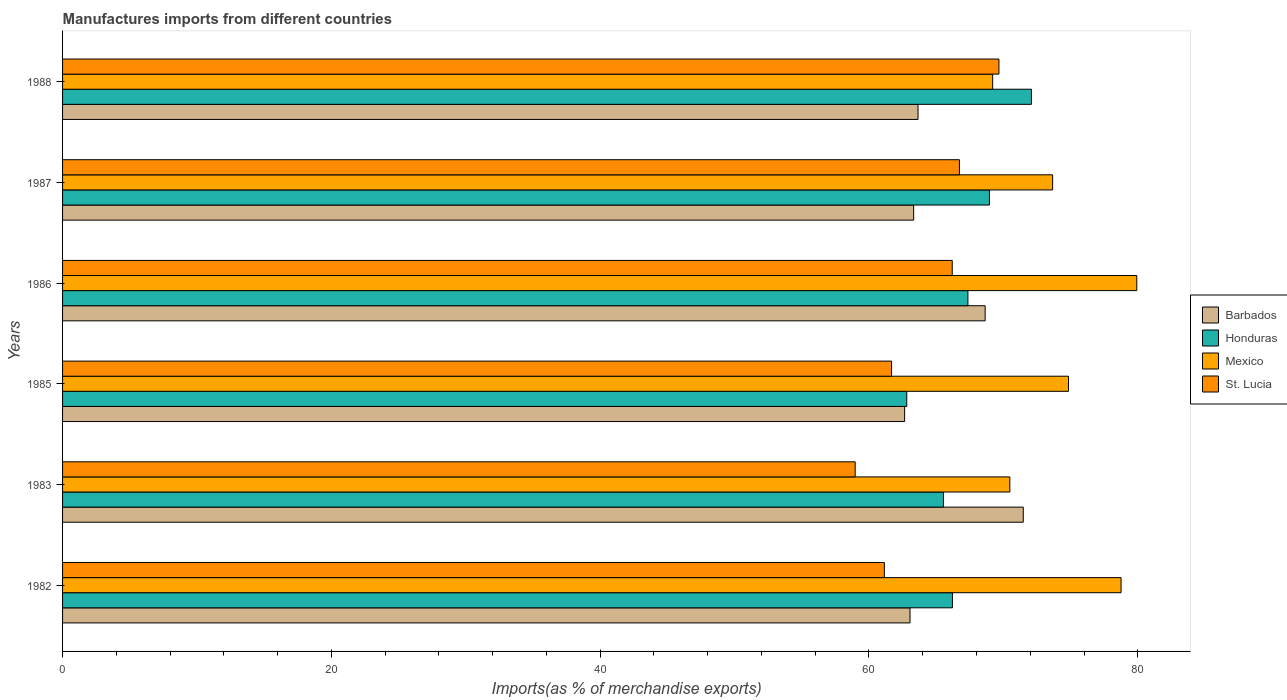How many different coloured bars are there?
Make the answer very short. 4. In how many cases, is the number of bars for a given year not equal to the number of legend labels?
Offer a terse response. 0. What is the percentage of imports to different countries in Mexico in 1985?
Keep it short and to the point. 74.84. Across all years, what is the maximum percentage of imports to different countries in Barbados?
Your answer should be very brief. 71.48. Across all years, what is the minimum percentage of imports to different countries in Honduras?
Your answer should be compact. 62.81. In which year was the percentage of imports to different countries in Mexico maximum?
Provide a succinct answer. 1986. What is the total percentage of imports to different countries in Honduras in the graph?
Offer a terse response. 402.97. What is the difference between the percentage of imports to different countries in Honduras in 1986 and that in 1988?
Offer a very short reply. -4.73. What is the difference between the percentage of imports to different countries in Mexico in 1987 and the percentage of imports to different countries in Barbados in 1983?
Ensure brevity in your answer.  2.19. What is the average percentage of imports to different countries in Honduras per year?
Your answer should be compact. 67.16. In the year 1985, what is the difference between the percentage of imports to different countries in St. Lucia and percentage of imports to different countries in Barbados?
Provide a succinct answer. -0.97. In how many years, is the percentage of imports to different countries in Mexico greater than 76 %?
Ensure brevity in your answer.  2. What is the ratio of the percentage of imports to different countries in St. Lucia in 1985 to that in 1986?
Provide a short and direct response. 0.93. Is the percentage of imports to different countries in St. Lucia in 1985 less than that in 1988?
Provide a succinct answer. Yes. What is the difference between the highest and the second highest percentage of imports to different countries in Honduras?
Make the answer very short. 3.12. What is the difference between the highest and the lowest percentage of imports to different countries in Barbados?
Give a very brief answer. 8.83. Is the sum of the percentage of imports to different countries in St. Lucia in 1982 and 1986 greater than the maximum percentage of imports to different countries in Barbados across all years?
Provide a succinct answer. Yes. What does the 2nd bar from the top in 1987 represents?
Provide a short and direct response. Mexico. What does the 3rd bar from the bottom in 1983 represents?
Your answer should be compact. Mexico. Is it the case that in every year, the sum of the percentage of imports to different countries in Barbados and percentage of imports to different countries in St. Lucia is greater than the percentage of imports to different countries in Honduras?
Ensure brevity in your answer.  Yes. Are all the bars in the graph horizontal?
Offer a very short reply. Yes. Are the values on the major ticks of X-axis written in scientific E-notation?
Keep it short and to the point. No. Does the graph contain grids?
Provide a succinct answer. No. How many legend labels are there?
Provide a succinct answer. 4. How are the legend labels stacked?
Keep it short and to the point. Vertical. What is the title of the graph?
Make the answer very short. Manufactures imports from different countries. Does "Netherlands" appear as one of the legend labels in the graph?
Ensure brevity in your answer.  No. What is the label or title of the X-axis?
Keep it short and to the point. Imports(as % of merchandise exports). What is the label or title of the Y-axis?
Offer a terse response. Years. What is the Imports(as % of merchandise exports) in Barbados in 1982?
Keep it short and to the point. 63.05. What is the Imports(as % of merchandise exports) in Honduras in 1982?
Make the answer very short. 66.21. What is the Imports(as % of merchandise exports) in Mexico in 1982?
Offer a very short reply. 78.76. What is the Imports(as % of merchandise exports) of St. Lucia in 1982?
Ensure brevity in your answer.  61.14. What is the Imports(as % of merchandise exports) in Barbados in 1983?
Offer a terse response. 71.48. What is the Imports(as % of merchandise exports) of Honduras in 1983?
Provide a short and direct response. 65.54. What is the Imports(as % of merchandise exports) of Mexico in 1983?
Ensure brevity in your answer.  70.48. What is the Imports(as % of merchandise exports) of St. Lucia in 1983?
Provide a short and direct response. 58.97. What is the Imports(as % of merchandise exports) in Barbados in 1985?
Provide a succinct answer. 62.65. What is the Imports(as % of merchandise exports) in Honduras in 1985?
Your answer should be compact. 62.81. What is the Imports(as % of merchandise exports) of Mexico in 1985?
Offer a very short reply. 74.84. What is the Imports(as % of merchandise exports) in St. Lucia in 1985?
Provide a succinct answer. 61.68. What is the Imports(as % of merchandise exports) of Barbados in 1986?
Make the answer very short. 68.64. What is the Imports(as % of merchandise exports) of Honduras in 1986?
Make the answer very short. 67.36. What is the Imports(as % of merchandise exports) in Mexico in 1986?
Keep it short and to the point. 79.93. What is the Imports(as % of merchandise exports) of St. Lucia in 1986?
Your answer should be compact. 66.19. What is the Imports(as % of merchandise exports) of Barbados in 1987?
Provide a succinct answer. 63.32. What is the Imports(as % of merchandise exports) of Honduras in 1987?
Provide a short and direct response. 68.96. What is the Imports(as % of merchandise exports) in Mexico in 1987?
Offer a terse response. 73.66. What is the Imports(as % of merchandise exports) of St. Lucia in 1987?
Your answer should be very brief. 66.73. What is the Imports(as % of merchandise exports) in Barbados in 1988?
Provide a short and direct response. 63.65. What is the Imports(as % of merchandise exports) of Honduras in 1988?
Your answer should be very brief. 72.09. What is the Imports(as % of merchandise exports) in Mexico in 1988?
Your response must be concise. 69.2. What is the Imports(as % of merchandise exports) in St. Lucia in 1988?
Make the answer very short. 69.67. Across all years, what is the maximum Imports(as % of merchandise exports) of Barbados?
Make the answer very short. 71.48. Across all years, what is the maximum Imports(as % of merchandise exports) of Honduras?
Give a very brief answer. 72.09. Across all years, what is the maximum Imports(as % of merchandise exports) of Mexico?
Your answer should be very brief. 79.93. Across all years, what is the maximum Imports(as % of merchandise exports) in St. Lucia?
Make the answer very short. 69.67. Across all years, what is the minimum Imports(as % of merchandise exports) in Barbados?
Give a very brief answer. 62.65. Across all years, what is the minimum Imports(as % of merchandise exports) in Honduras?
Your answer should be compact. 62.81. Across all years, what is the minimum Imports(as % of merchandise exports) in Mexico?
Keep it short and to the point. 69.2. Across all years, what is the minimum Imports(as % of merchandise exports) of St. Lucia?
Your response must be concise. 58.97. What is the total Imports(as % of merchandise exports) in Barbados in the graph?
Your response must be concise. 392.8. What is the total Imports(as % of merchandise exports) in Honduras in the graph?
Your answer should be compact. 402.97. What is the total Imports(as % of merchandise exports) in Mexico in the graph?
Provide a succinct answer. 446.87. What is the total Imports(as % of merchandise exports) of St. Lucia in the graph?
Your answer should be compact. 384.39. What is the difference between the Imports(as % of merchandise exports) of Barbados in 1982 and that in 1983?
Provide a short and direct response. -8.43. What is the difference between the Imports(as % of merchandise exports) of Honduras in 1982 and that in 1983?
Keep it short and to the point. 0.67. What is the difference between the Imports(as % of merchandise exports) in Mexico in 1982 and that in 1983?
Offer a very short reply. 8.27. What is the difference between the Imports(as % of merchandise exports) of St. Lucia in 1982 and that in 1983?
Your answer should be very brief. 2.17. What is the difference between the Imports(as % of merchandise exports) in Barbados in 1982 and that in 1985?
Provide a succinct answer. 0.4. What is the difference between the Imports(as % of merchandise exports) in Honduras in 1982 and that in 1985?
Ensure brevity in your answer.  3.4. What is the difference between the Imports(as % of merchandise exports) of Mexico in 1982 and that in 1985?
Offer a terse response. 3.91. What is the difference between the Imports(as % of merchandise exports) in St. Lucia in 1982 and that in 1985?
Keep it short and to the point. -0.54. What is the difference between the Imports(as % of merchandise exports) of Barbados in 1982 and that in 1986?
Your response must be concise. -5.59. What is the difference between the Imports(as % of merchandise exports) in Honduras in 1982 and that in 1986?
Provide a succinct answer. -1.15. What is the difference between the Imports(as % of merchandise exports) of Mexico in 1982 and that in 1986?
Ensure brevity in your answer.  -1.17. What is the difference between the Imports(as % of merchandise exports) of St. Lucia in 1982 and that in 1986?
Offer a terse response. -5.05. What is the difference between the Imports(as % of merchandise exports) of Barbados in 1982 and that in 1987?
Your answer should be compact. -0.27. What is the difference between the Imports(as % of merchandise exports) of Honduras in 1982 and that in 1987?
Your response must be concise. -2.75. What is the difference between the Imports(as % of merchandise exports) in Mexico in 1982 and that in 1987?
Ensure brevity in your answer.  5.09. What is the difference between the Imports(as % of merchandise exports) in St. Lucia in 1982 and that in 1987?
Your response must be concise. -5.58. What is the difference between the Imports(as % of merchandise exports) of Barbados in 1982 and that in 1988?
Give a very brief answer. -0.6. What is the difference between the Imports(as % of merchandise exports) in Honduras in 1982 and that in 1988?
Offer a very short reply. -5.88. What is the difference between the Imports(as % of merchandise exports) in Mexico in 1982 and that in 1988?
Offer a terse response. 9.55. What is the difference between the Imports(as % of merchandise exports) in St. Lucia in 1982 and that in 1988?
Your answer should be very brief. -8.52. What is the difference between the Imports(as % of merchandise exports) in Barbados in 1983 and that in 1985?
Offer a terse response. 8.83. What is the difference between the Imports(as % of merchandise exports) in Honduras in 1983 and that in 1985?
Make the answer very short. 2.73. What is the difference between the Imports(as % of merchandise exports) in Mexico in 1983 and that in 1985?
Make the answer very short. -4.36. What is the difference between the Imports(as % of merchandise exports) of St. Lucia in 1983 and that in 1985?
Offer a terse response. -2.71. What is the difference between the Imports(as % of merchandise exports) of Barbados in 1983 and that in 1986?
Ensure brevity in your answer.  2.84. What is the difference between the Imports(as % of merchandise exports) of Honduras in 1983 and that in 1986?
Give a very brief answer. -1.82. What is the difference between the Imports(as % of merchandise exports) of Mexico in 1983 and that in 1986?
Offer a terse response. -9.44. What is the difference between the Imports(as % of merchandise exports) of St. Lucia in 1983 and that in 1986?
Make the answer very short. -7.22. What is the difference between the Imports(as % of merchandise exports) of Barbados in 1983 and that in 1987?
Offer a terse response. 8.16. What is the difference between the Imports(as % of merchandise exports) in Honduras in 1983 and that in 1987?
Your response must be concise. -3.42. What is the difference between the Imports(as % of merchandise exports) in Mexico in 1983 and that in 1987?
Your answer should be compact. -3.18. What is the difference between the Imports(as % of merchandise exports) in St. Lucia in 1983 and that in 1987?
Your answer should be very brief. -7.76. What is the difference between the Imports(as % of merchandise exports) of Barbados in 1983 and that in 1988?
Provide a short and direct response. 7.83. What is the difference between the Imports(as % of merchandise exports) of Honduras in 1983 and that in 1988?
Your response must be concise. -6.55. What is the difference between the Imports(as % of merchandise exports) of Mexico in 1983 and that in 1988?
Ensure brevity in your answer.  1.28. What is the difference between the Imports(as % of merchandise exports) of St. Lucia in 1983 and that in 1988?
Keep it short and to the point. -10.7. What is the difference between the Imports(as % of merchandise exports) of Barbados in 1985 and that in 1986?
Your response must be concise. -5.99. What is the difference between the Imports(as % of merchandise exports) of Honduras in 1985 and that in 1986?
Provide a succinct answer. -4.55. What is the difference between the Imports(as % of merchandise exports) of Mexico in 1985 and that in 1986?
Provide a short and direct response. -5.08. What is the difference between the Imports(as % of merchandise exports) of St. Lucia in 1985 and that in 1986?
Your answer should be very brief. -4.51. What is the difference between the Imports(as % of merchandise exports) of Barbados in 1985 and that in 1987?
Keep it short and to the point. -0.67. What is the difference between the Imports(as % of merchandise exports) in Honduras in 1985 and that in 1987?
Keep it short and to the point. -6.15. What is the difference between the Imports(as % of merchandise exports) in Mexico in 1985 and that in 1987?
Your response must be concise. 1.18. What is the difference between the Imports(as % of merchandise exports) in St. Lucia in 1985 and that in 1987?
Give a very brief answer. -5.05. What is the difference between the Imports(as % of merchandise exports) of Barbados in 1985 and that in 1988?
Your answer should be compact. -1. What is the difference between the Imports(as % of merchandise exports) in Honduras in 1985 and that in 1988?
Your answer should be very brief. -9.28. What is the difference between the Imports(as % of merchandise exports) of Mexico in 1985 and that in 1988?
Provide a succinct answer. 5.64. What is the difference between the Imports(as % of merchandise exports) in St. Lucia in 1985 and that in 1988?
Your answer should be very brief. -7.99. What is the difference between the Imports(as % of merchandise exports) in Barbados in 1986 and that in 1987?
Ensure brevity in your answer.  5.32. What is the difference between the Imports(as % of merchandise exports) in Honduras in 1986 and that in 1987?
Keep it short and to the point. -1.6. What is the difference between the Imports(as % of merchandise exports) of Mexico in 1986 and that in 1987?
Provide a succinct answer. 6.26. What is the difference between the Imports(as % of merchandise exports) of St. Lucia in 1986 and that in 1987?
Keep it short and to the point. -0.53. What is the difference between the Imports(as % of merchandise exports) of Barbados in 1986 and that in 1988?
Offer a very short reply. 4.99. What is the difference between the Imports(as % of merchandise exports) of Honduras in 1986 and that in 1988?
Give a very brief answer. -4.73. What is the difference between the Imports(as % of merchandise exports) in Mexico in 1986 and that in 1988?
Provide a succinct answer. 10.72. What is the difference between the Imports(as % of merchandise exports) in St. Lucia in 1986 and that in 1988?
Make the answer very short. -3.47. What is the difference between the Imports(as % of merchandise exports) in Barbados in 1987 and that in 1988?
Offer a terse response. -0.33. What is the difference between the Imports(as % of merchandise exports) in Honduras in 1987 and that in 1988?
Provide a succinct answer. -3.12. What is the difference between the Imports(as % of merchandise exports) in Mexico in 1987 and that in 1988?
Provide a short and direct response. 4.46. What is the difference between the Imports(as % of merchandise exports) in St. Lucia in 1987 and that in 1988?
Provide a succinct answer. -2.94. What is the difference between the Imports(as % of merchandise exports) of Barbados in 1982 and the Imports(as % of merchandise exports) of Honduras in 1983?
Your response must be concise. -2.48. What is the difference between the Imports(as % of merchandise exports) in Barbados in 1982 and the Imports(as % of merchandise exports) in Mexico in 1983?
Keep it short and to the point. -7.43. What is the difference between the Imports(as % of merchandise exports) of Barbados in 1982 and the Imports(as % of merchandise exports) of St. Lucia in 1983?
Keep it short and to the point. 4.08. What is the difference between the Imports(as % of merchandise exports) of Honduras in 1982 and the Imports(as % of merchandise exports) of Mexico in 1983?
Your answer should be compact. -4.27. What is the difference between the Imports(as % of merchandise exports) in Honduras in 1982 and the Imports(as % of merchandise exports) in St. Lucia in 1983?
Keep it short and to the point. 7.24. What is the difference between the Imports(as % of merchandise exports) of Mexico in 1982 and the Imports(as % of merchandise exports) of St. Lucia in 1983?
Offer a very short reply. 19.78. What is the difference between the Imports(as % of merchandise exports) of Barbados in 1982 and the Imports(as % of merchandise exports) of Honduras in 1985?
Provide a succinct answer. 0.24. What is the difference between the Imports(as % of merchandise exports) in Barbados in 1982 and the Imports(as % of merchandise exports) in Mexico in 1985?
Make the answer very short. -11.79. What is the difference between the Imports(as % of merchandise exports) in Barbados in 1982 and the Imports(as % of merchandise exports) in St. Lucia in 1985?
Keep it short and to the point. 1.37. What is the difference between the Imports(as % of merchandise exports) in Honduras in 1982 and the Imports(as % of merchandise exports) in Mexico in 1985?
Your answer should be compact. -8.64. What is the difference between the Imports(as % of merchandise exports) of Honduras in 1982 and the Imports(as % of merchandise exports) of St. Lucia in 1985?
Offer a very short reply. 4.53. What is the difference between the Imports(as % of merchandise exports) in Mexico in 1982 and the Imports(as % of merchandise exports) in St. Lucia in 1985?
Your response must be concise. 17.07. What is the difference between the Imports(as % of merchandise exports) of Barbados in 1982 and the Imports(as % of merchandise exports) of Honduras in 1986?
Provide a short and direct response. -4.31. What is the difference between the Imports(as % of merchandise exports) in Barbados in 1982 and the Imports(as % of merchandise exports) in Mexico in 1986?
Offer a very short reply. -16.87. What is the difference between the Imports(as % of merchandise exports) of Barbados in 1982 and the Imports(as % of merchandise exports) of St. Lucia in 1986?
Offer a terse response. -3.14. What is the difference between the Imports(as % of merchandise exports) of Honduras in 1982 and the Imports(as % of merchandise exports) of Mexico in 1986?
Offer a very short reply. -13.72. What is the difference between the Imports(as % of merchandise exports) of Honduras in 1982 and the Imports(as % of merchandise exports) of St. Lucia in 1986?
Keep it short and to the point. 0.01. What is the difference between the Imports(as % of merchandise exports) in Mexico in 1982 and the Imports(as % of merchandise exports) in St. Lucia in 1986?
Your answer should be very brief. 12.56. What is the difference between the Imports(as % of merchandise exports) of Barbados in 1982 and the Imports(as % of merchandise exports) of Honduras in 1987?
Provide a succinct answer. -5.91. What is the difference between the Imports(as % of merchandise exports) in Barbados in 1982 and the Imports(as % of merchandise exports) in Mexico in 1987?
Your answer should be very brief. -10.61. What is the difference between the Imports(as % of merchandise exports) of Barbados in 1982 and the Imports(as % of merchandise exports) of St. Lucia in 1987?
Your response must be concise. -3.68. What is the difference between the Imports(as % of merchandise exports) of Honduras in 1982 and the Imports(as % of merchandise exports) of Mexico in 1987?
Ensure brevity in your answer.  -7.46. What is the difference between the Imports(as % of merchandise exports) of Honduras in 1982 and the Imports(as % of merchandise exports) of St. Lucia in 1987?
Make the answer very short. -0.52. What is the difference between the Imports(as % of merchandise exports) of Mexico in 1982 and the Imports(as % of merchandise exports) of St. Lucia in 1987?
Make the answer very short. 12.03. What is the difference between the Imports(as % of merchandise exports) in Barbados in 1982 and the Imports(as % of merchandise exports) in Honduras in 1988?
Offer a terse response. -9.03. What is the difference between the Imports(as % of merchandise exports) of Barbados in 1982 and the Imports(as % of merchandise exports) of Mexico in 1988?
Ensure brevity in your answer.  -6.15. What is the difference between the Imports(as % of merchandise exports) of Barbados in 1982 and the Imports(as % of merchandise exports) of St. Lucia in 1988?
Keep it short and to the point. -6.62. What is the difference between the Imports(as % of merchandise exports) in Honduras in 1982 and the Imports(as % of merchandise exports) in Mexico in 1988?
Your answer should be compact. -2.99. What is the difference between the Imports(as % of merchandise exports) of Honduras in 1982 and the Imports(as % of merchandise exports) of St. Lucia in 1988?
Make the answer very short. -3.46. What is the difference between the Imports(as % of merchandise exports) of Mexico in 1982 and the Imports(as % of merchandise exports) of St. Lucia in 1988?
Provide a succinct answer. 9.09. What is the difference between the Imports(as % of merchandise exports) in Barbados in 1983 and the Imports(as % of merchandise exports) in Honduras in 1985?
Provide a short and direct response. 8.67. What is the difference between the Imports(as % of merchandise exports) in Barbados in 1983 and the Imports(as % of merchandise exports) in Mexico in 1985?
Your answer should be compact. -3.36. What is the difference between the Imports(as % of merchandise exports) in Barbados in 1983 and the Imports(as % of merchandise exports) in St. Lucia in 1985?
Offer a terse response. 9.8. What is the difference between the Imports(as % of merchandise exports) of Honduras in 1983 and the Imports(as % of merchandise exports) of Mexico in 1985?
Make the answer very short. -9.31. What is the difference between the Imports(as % of merchandise exports) of Honduras in 1983 and the Imports(as % of merchandise exports) of St. Lucia in 1985?
Your answer should be compact. 3.86. What is the difference between the Imports(as % of merchandise exports) in Mexico in 1983 and the Imports(as % of merchandise exports) in St. Lucia in 1985?
Provide a succinct answer. 8.8. What is the difference between the Imports(as % of merchandise exports) of Barbados in 1983 and the Imports(as % of merchandise exports) of Honduras in 1986?
Your answer should be very brief. 4.12. What is the difference between the Imports(as % of merchandise exports) in Barbados in 1983 and the Imports(as % of merchandise exports) in Mexico in 1986?
Your response must be concise. -8.45. What is the difference between the Imports(as % of merchandise exports) of Barbados in 1983 and the Imports(as % of merchandise exports) of St. Lucia in 1986?
Provide a short and direct response. 5.28. What is the difference between the Imports(as % of merchandise exports) of Honduras in 1983 and the Imports(as % of merchandise exports) of Mexico in 1986?
Ensure brevity in your answer.  -14.39. What is the difference between the Imports(as % of merchandise exports) of Honduras in 1983 and the Imports(as % of merchandise exports) of St. Lucia in 1986?
Give a very brief answer. -0.66. What is the difference between the Imports(as % of merchandise exports) in Mexico in 1983 and the Imports(as % of merchandise exports) in St. Lucia in 1986?
Keep it short and to the point. 4.29. What is the difference between the Imports(as % of merchandise exports) of Barbados in 1983 and the Imports(as % of merchandise exports) of Honduras in 1987?
Ensure brevity in your answer.  2.52. What is the difference between the Imports(as % of merchandise exports) of Barbados in 1983 and the Imports(as % of merchandise exports) of Mexico in 1987?
Give a very brief answer. -2.19. What is the difference between the Imports(as % of merchandise exports) of Barbados in 1983 and the Imports(as % of merchandise exports) of St. Lucia in 1987?
Offer a terse response. 4.75. What is the difference between the Imports(as % of merchandise exports) in Honduras in 1983 and the Imports(as % of merchandise exports) in Mexico in 1987?
Your answer should be very brief. -8.13. What is the difference between the Imports(as % of merchandise exports) of Honduras in 1983 and the Imports(as % of merchandise exports) of St. Lucia in 1987?
Ensure brevity in your answer.  -1.19. What is the difference between the Imports(as % of merchandise exports) in Mexico in 1983 and the Imports(as % of merchandise exports) in St. Lucia in 1987?
Provide a succinct answer. 3.75. What is the difference between the Imports(as % of merchandise exports) in Barbados in 1983 and the Imports(as % of merchandise exports) in Honduras in 1988?
Offer a very short reply. -0.61. What is the difference between the Imports(as % of merchandise exports) of Barbados in 1983 and the Imports(as % of merchandise exports) of Mexico in 1988?
Offer a terse response. 2.28. What is the difference between the Imports(as % of merchandise exports) of Barbados in 1983 and the Imports(as % of merchandise exports) of St. Lucia in 1988?
Provide a short and direct response. 1.81. What is the difference between the Imports(as % of merchandise exports) in Honduras in 1983 and the Imports(as % of merchandise exports) in Mexico in 1988?
Make the answer very short. -3.66. What is the difference between the Imports(as % of merchandise exports) in Honduras in 1983 and the Imports(as % of merchandise exports) in St. Lucia in 1988?
Your response must be concise. -4.13. What is the difference between the Imports(as % of merchandise exports) in Mexico in 1983 and the Imports(as % of merchandise exports) in St. Lucia in 1988?
Keep it short and to the point. 0.81. What is the difference between the Imports(as % of merchandise exports) of Barbados in 1985 and the Imports(as % of merchandise exports) of Honduras in 1986?
Offer a terse response. -4.71. What is the difference between the Imports(as % of merchandise exports) of Barbados in 1985 and the Imports(as % of merchandise exports) of Mexico in 1986?
Ensure brevity in your answer.  -17.27. What is the difference between the Imports(as % of merchandise exports) of Barbados in 1985 and the Imports(as % of merchandise exports) of St. Lucia in 1986?
Give a very brief answer. -3.54. What is the difference between the Imports(as % of merchandise exports) of Honduras in 1985 and the Imports(as % of merchandise exports) of Mexico in 1986?
Provide a succinct answer. -17.12. What is the difference between the Imports(as % of merchandise exports) of Honduras in 1985 and the Imports(as % of merchandise exports) of St. Lucia in 1986?
Offer a very short reply. -3.38. What is the difference between the Imports(as % of merchandise exports) of Mexico in 1985 and the Imports(as % of merchandise exports) of St. Lucia in 1986?
Provide a short and direct response. 8.65. What is the difference between the Imports(as % of merchandise exports) in Barbados in 1985 and the Imports(as % of merchandise exports) in Honduras in 1987?
Keep it short and to the point. -6.31. What is the difference between the Imports(as % of merchandise exports) of Barbados in 1985 and the Imports(as % of merchandise exports) of Mexico in 1987?
Ensure brevity in your answer.  -11.01. What is the difference between the Imports(as % of merchandise exports) of Barbados in 1985 and the Imports(as % of merchandise exports) of St. Lucia in 1987?
Offer a terse response. -4.08. What is the difference between the Imports(as % of merchandise exports) in Honduras in 1985 and the Imports(as % of merchandise exports) in Mexico in 1987?
Your answer should be compact. -10.85. What is the difference between the Imports(as % of merchandise exports) in Honduras in 1985 and the Imports(as % of merchandise exports) in St. Lucia in 1987?
Provide a succinct answer. -3.92. What is the difference between the Imports(as % of merchandise exports) of Mexico in 1985 and the Imports(as % of merchandise exports) of St. Lucia in 1987?
Provide a succinct answer. 8.12. What is the difference between the Imports(as % of merchandise exports) of Barbados in 1985 and the Imports(as % of merchandise exports) of Honduras in 1988?
Offer a very short reply. -9.44. What is the difference between the Imports(as % of merchandise exports) of Barbados in 1985 and the Imports(as % of merchandise exports) of Mexico in 1988?
Keep it short and to the point. -6.55. What is the difference between the Imports(as % of merchandise exports) in Barbados in 1985 and the Imports(as % of merchandise exports) in St. Lucia in 1988?
Provide a short and direct response. -7.02. What is the difference between the Imports(as % of merchandise exports) of Honduras in 1985 and the Imports(as % of merchandise exports) of Mexico in 1988?
Offer a very short reply. -6.39. What is the difference between the Imports(as % of merchandise exports) of Honduras in 1985 and the Imports(as % of merchandise exports) of St. Lucia in 1988?
Provide a short and direct response. -6.86. What is the difference between the Imports(as % of merchandise exports) in Mexico in 1985 and the Imports(as % of merchandise exports) in St. Lucia in 1988?
Offer a very short reply. 5.17. What is the difference between the Imports(as % of merchandise exports) of Barbados in 1986 and the Imports(as % of merchandise exports) of Honduras in 1987?
Your response must be concise. -0.32. What is the difference between the Imports(as % of merchandise exports) in Barbados in 1986 and the Imports(as % of merchandise exports) in Mexico in 1987?
Provide a short and direct response. -5.02. What is the difference between the Imports(as % of merchandise exports) in Barbados in 1986 and the Imports(as % of merchandise exports) in St. Lucia in 1987?
Provide a short and direct response. 1.91. What is the difference between the Imports(as % of merchandise exports) in Honduras in 1986 and the Imports(as % of merchandise exports) in Mexico in 1987?
Keep it short and to the point. -6.3. What is the difference between the Imports(as % of merchandise exports) in Honduras in 1986 and the Imports(as % of merchandise exports) in St. Lucia in 1987?
Make the answer very short. 0.63. What is the difference between the Imports(as % of merchandise exports) of Mexico in 1986 and the Imports(as % of merchandise exports) of St. Lucia in 1987?
Make the answer very short. 13.2. What is the difference between the Imports(as % of merchandise exports) in Barbados in 1986 and the Imports(as % of merchandise exports) in Honduras in 1988?
Make the answer very short. -3.44. What is the difference between the Imports(as % of merchandise exports) in Barbados in 1986 and the Imports(as % of merchandise exports) in Mexico in 1988?
Provide a short and direct response. -0.56. What is the difference between the Imports(as % of merchandise exports) in Barbados in 1986 and the Imports(as % of merchandise exports) in St. Lucia in 1988?
Your answer should be compact. -1.03. What is the difference between the Imports(as % of merchandise exports) in Honduras in 1986 and the Imports(as % of merchandise exports) in Mexico in 1988?
Your response must be concise. -1.84. What is the difference between the Imports(as % of merchandise exports) of Honduras in 1986 and the Imports(as % of merchandise exports) of St. Lucia in 1988?
Offer a very short reply. -2.31. What is the difference between the Imports(as % of merchandise exports) of Mexico in 1986 and the Imports(as % of merchandise exports) of St. Lucia in 1988?
Offer a terse response. 10.26. What is the difference between the Imports(as % of merchandise exports) of Barbados in 1987 and the Imports(as % of merchandise exports) of Honduras in 1988?
Offer a terse response. -8.76. What is the difference between the Imports(as % of merchandise exports) of Barbados in 1987 and the Imports(as % of merchandise exports) of Mexico in 1988?
Give a very brief answer. -5.88. What is the difference between the Imports(as % of merchandise exports) of Barbados in 1987 and the Imports(as % of merchandise exports) of St. Lucia in 1988?
Your response must be concise. -6.35. What is the difference between the Imports(as % of merchandise exports) in Honduras in 1987 and the Imports(as % of merchandise exports) in Mexico in 1988?
Offer a very short reply. -0.24. What is the difference between the Imports(as % of merchandise exports) in Honduras in 1987 and the Imports(as % of merchandise exports) in St. Lucia in 1988?
Your response must be concise. -0.71. What is the difference between the Imports(as % of merchandise exports) of Mexico in 1987 and the Imports(as % of merchandise exports) of St. Lucia in 1988?
Ensure brevity in your answer.  4. What is the average Imports(as % of merchandise exports) in Barbados per year?
Offer a terse response. 65.47. What is the average Imports(as % of merchandise exports) of Honduras per year?
Offer a terse response. 67.16. What is the average Imports(as % of merchandise exports) of Mexico per year?
Your answer should be compact. 74.48. What is the average Imports(as % of merchandise exports) in St. Lucia per year?
Offer a very short reply. 64.07. In the year 1982, what is the difference between the Imports(as % of merchandise exports) of Barbados and Imports(as % of merchandise exports) of Honduras?
Provide a succinct answer. -3.16. In the year 1982, what is the difference between the Imports(as % of merchandise exports) of Barbados and Imports(as % of merchandise exports) of Mexico?
Offer a terse response. -15.7. In the year 1982, what is the difference between the Imports(as % of merchandise exports) of Barbados and Imports(as % of merchandise exports) of St. Lucia?
Offer a very short reply. 1.91. In the year 1982, what is the difference between the Imports(as % of merchandise exports) in Honduras and Imports(as % of merchandise exports) in Mexico?
Provide a succinct answer. -12.55. In the year 1982, what is the difference between the Imports(as % of merchandise exports) in Honduras and Imports(as % of merchandise exports) in St. Lucia?
Your answer should be compact. 5.06. In the year 1982, what is the difference between the Imports(as % of merchandise exports) of Mexico and Imports(as % of merchandise exports) of St. Lucia?
Keep it short and to the point. 17.61. In the year 1983, what is the difference between the Imports(as % of merchandise exports) of Barbados and Imports(as % of merchandise exports) of Honduras?
Your response must be concise. 5.94. In the year 1983, what is the difference between the Imports(as % of merchandise exports) of Barbados and Imports(as % of merchandise exports) of Mexico?
Ensure brevity in your answer.  1. In the year 1983, what is the difference between the Imports(as % of merchandise exports) of Barbados and Imports(as % of merchandise exports) of St. Lucia?
Ensure brevity in your answer.  12.51. In the year 1983, what is the difference between the Imports(as % of merchandise exports) in Honduras and Imports(as % of merchandise exports) in Mexico?
Your answer should be very brief. -4.94. In the year 1983, what is the difference between the Imports(as % of merchandise exports) in Honduras and Imports(as % of merchandise exports) in St. Lucia?
Offer a terse response. 6.57. In the year 1983, what is the difference between the Imports(as % of merchandise exports) in Mexico and Imports(as % of merchandise exports) in St. Lucia?
Provide a succinct answer. 11.51. In the year 1985, what is the difference between the Imports(as % of merchandise exports) of Barbados and Imports(as % of merchandise exports) of Honduras?
Provide a succinct answer. -0.16. In the year 1985, what is the difference between the Imports(as % of merchandise exports) in Barbados and Imports(as % of merchandise exports) in Mexico?
Offer a terse response. -12.19. In the year 1985, what is the difference between the Imports(as % of merchandise exports) in Barbados and Imports(as % of merchandise exports) in St. Lucia?
Keep it short and to the point. 0.97. In the year 1985, what is the difference between the Imports(as % of merchandise exports) in Honduras and Imports(as % of merchandise exports) in Mexico?
Provide a short and direct response. -12.03. In the year 1985, what is the difference between the Imports(as % of merchandise exports) of Honduras and Imports(as % of merchandise exports) of St. Lucia?
Offer a very short reply. 1.13. In the year 1985, what is the difference between the Imports(as % of merchandise exports) of Mexico and Imports(as % of merchandise exports) of St. Lucia?
Offer a terse response. 13.16. In the year 1986, what is the difference between the Imports(as % of merchandise exports) in Barbados and Imports(as % of merchandise exports) in Honduras?
Offer a terse response. 1.28. In the year 1986, what is the difference between the Imports(as % of merchandise exports) of Barbados and Imports(as % of merchandise exports) of Mexico?
Your response must be concise. -11.28. In the year 1986, what is the difference between the Imports(as % of merchandise exports) of Barbados and Imports(as % of merchandise exports) of St. Lucia?
Give a very brief answer. 2.45. In the year 1986, what is the difference between the Imports(as % of merchandise exports) in Honduras and Imports(as % of merchandise exports) in Mexico?
Your answer should be compact. -12.57. In the year 1986, what is the difference between the Imports(as % of merchandise exports) of Honduras and Imports(as % of merchandise exports) of St. Lucia?
Keep it short and to the point. 1.17. In the year 1986, what is the difference between the Imports(as % of merchandise exports) in Mexico and Imports(as % of merchandise exports) in St. Lucia?
Provide a short and direct response. 13.73. In the year 1987, what is the difference between the Imports(as % of merchandise exports) of Barbados and Imports(as % of merchandise exports) of Honduras?
Give a very brief answer. -5.64. In the year 1987, what is the difference between the Imports(as % of merchandise exports) in Barbados and Imports(as % of merchandise exports) in Mexico?
Provide a succinct answer. -10.34. In the year 1987, what is the difference between the Imports(as % of merchandise exports) of Barbados and Imports(as % of merchandise exports) of St. Lucia?
Your response must be concise. -3.41. In the year 1987, what is the difference between the Imports(as % of merchandise exports) of Honduras and Imports(as % of merchandise exports) of Mexico?
Your answer should be compact. -4.7. In the year 1987, what is the difference between the Imports(as % of merchandise exports) in Honduras and Imports(as % of merchandise exports) in St. Lucia?
Ensure brevity in your answer.  2.23. In the year 1987, what is the difference between the Imports(as % of merchandise exports) of Mexico and Imports(as % of merchandise exports) of St. Lucia?
Offer a very short reply. 6.94. In the year 1988, what is the difference between the Imports(as % of merchandise exports) in Barbados and Imports(as % of merchandise exports) in Honduras?
Your answer should be very brief. -8.44. In the year 1988, what is the difference between the Imports(as % of merchandise exports) of Barbados and Imports(as % of merchandise exports) of Mexico?
Provide a short and direct response. -5.55. In the year 1988, what is the difference between the Imports(as % of merchandise exports) of Barbados and Imports(as % of merchandise exports) of St. Lucia?
Ensure brevity in your answer.  -6.02. In the year 1988, what is the difference between the Imports(as % of merchandise exports) in Honduras and Imports(as % of merchandise exports) in Mexico?
Provide a short and direct response. 2.89. In the year 1988, what is the difference between the Imports(as % of merchandise exports) of Honduras and Imports(as % of merchandise exports) of St. Lucia?
Give a very brief answer. 2.42. In the year 1988, what is the difference between the Imports(as % of merchandise exports) of Mexico and Imports(as % of merchandise exports) of St. Lucia?
Offer a very short reply. -0.47. What is the ratio of the Imports(as % of merchandise exports) of Barbados in 1982 to that in 1983?
Provide a succinct answer. 0.88. What is the ratio of the Imports(as % of merchandise exports) of Honduras in 1982 to that in 1983?
Offer a terse response. 1.01. What is the ratio of the Imports(as % of merchandise exports) in Mexico in 1982 to that in 1983?
Keep it short and to the point. 1.12. What is the ratio of the Imports(as % of merchandise exports) in St. Lucia in 1982 to that in 1983?
Your answer should be very brief. 1.04. What is the ratio of the Imports(as % of merchandise exports) of Barbados in 1982 to that in 1985?
Keep it short and to the point. 1.01. What is the ratio of the Imports(as % of merchandise exports) of Honduras in 1982 to that in 1985?
Make the answer very short. 1.05. What is the ratio of the Imports(as % of merchandise exports) of Mexico in 1982 to that in 1985?
Offer a very short reply. 1.05. What is the ratio of the Imports(as % of merchandise exports) of Barbados in 1982 to that in 1986?
Your response must be concise. 0.92. What is the ratio of the Imports(as % of merchandise exports) of Honduras in 1982 to that in 1986?
Keep it short and to the point. 0.98. What is the ratio of the Imports(as % of merchandise exports) of Mexico in 1982 to that in 1986?
Give a very brief answer. 0.99. What is the ratio of the Imports(as % of merchandise exports) in St. Lucia in 1982 to that in 1986?
Provide a succinct answer. 0.92. What is the ratio of the Imports(as % of merchandise exports) in Honduras in 1982 to that in 1987?
Your answer should be very brief. 0.96. What is the ratio of the Imports(as % of merchandise exports) of Mexico in 1982 to that in 1987?
Give a very brief answer. 1.07. What is the ratio of the Imports(as % of merchandise exports) in St. Lucia in 1982 to that in 1987?
Offer a very short reply. 0.92. What is the ratio of the Imports(as % of merchandise exports) in Barbados in 1982 to that in 1988?
Ensure brevity in your answer.  0.99. What is the ratio of the Imports(as % of merchandise exports) in Honduras in 1982 to that in 1988?
Your response must be concise. 0.92. What is the ratio of the Imports(as % of merchandise exports) of Mexico in 1982 to that in 1988?
Provide a succinct answer. 1.14. What is the ratio of the Imports(as % of merchandise exports) in St. Lucia in 1982 to that in 1988?
Ensure brevity in your answer.  0.88. What is the ratio of the Imports(as % of merchandise exports) in Barbados in 1983 to that in 1985?
Your answer should be very brief. 1.14. What is the ratio of the Imports(as % of merchandise exports) of Honduras in 1983 to that in 1985?
Your answer should be compact. 1.04. What is the ratio of the Imports(as % of merchandise exports) in Mexico in 1983 to that in 1985?
Keep it short and to the point. 0.94. What is the ratio of the Imports(as % of merchandise exports) in St. Lucia in 1983 to that in 1985?
Give a very brief answer. 0.96. What is the ratio of the Imports(as % of merchandise exports) in Barbados in 1983 to that in 1986?
Your response must be concise. 1.04. What is the ratio of the Imports(as % of merchandise exports) in Honduras in 1983 to that in 1986?
Make the answer very short. 0.97. What is the ratio of the Imports(as % of merchandise exports) in Mexico in 1983 to that in 1986?
Your response must be concise. 0.88. What is the ratio of the Imports(as % of merchandise exports) in St. Lucia in 1983 to that in 1986?
Keep it short and to the point. 0.89. What is the ratio of the Imports(as % of merchandise exports) of Barbados in 1983 to that in 1987?
Your answer should be very brief. 1.13. What is the ratio of the Imports(as % of merchandise exports) in Honduras in 1983 to that in 1987?
Make the answer very short. 0.95. What is the ratio of the Imports(as % of merchandise exports) of Mexico in 1983 to that in 1987?
Ensure brevity in your answer.  0.96. What is the ratio of the Imports(as % of merchandise exports) in St. Lucia in 1983 to that in 1987?
Provide a succinct answer. 0.88. What is the ratio of the Imports(as % of merchandise exports) in Barbados in 1983 to that in 1988?
Offer a terse response. 1.12. What is the ratio of the Imports(as % of merchandise exports) of Mexico in 1983 to that in 1988?
Your answer should be compact. 1.02. What is the ratio of the Imports(as % of merchandise exports) of St. Lucia in 1983 to that in 1988?
Your answer should be compact. 0.85. What is the ratio of the Imports(as % of merchandise exports) of Barbados in 1985 to that in 1986?
Keep it short and to the point. 0.91. What is the ratio of the Imports(as % of merchandise exports) of Honduras in 1985 to that in 1986?
Ensure brevity in your answer.  0.93. What is the ratio of the Imports(as % of merchandise exports) of Mexico in 1985 to that in 1986?
Offer a very short reply. 0.94. What is the ratio of the Imports(as % of merchandise exports) in St. Lucia in 1985 to that in 1986?
Give a very brief answer. 0.93. What is the ratio of the Imports(as % of merchandise exports) in Honduras in 1985 to that in 1987?
Offer a terse response. 0.91. What is the ratio of the Imports(as % of merchandise exports) in St. Lucia in 1985 to that in 1987?
Your answer should be compact. 0.92. What is the ratio of the Imports(as % of merchandise exports) in Barbados in 1985 to that in 1988?
Ensure brevity in your answer.  0.98. What is the ratio of the Imports(as % of merchandise exports) of Honduras in 1985 to that in 1988?
Keep it short and to the point. 0.87. What is the ratio of the Imports(as % of merchandise exports) of Mexico in 1985 to that in 1988?
Ensure brevity in your answer.  1.08. What is the ratio of the Imports(as % of merchandise exports) of St. Lucia in 1985 to that in 1988?
Offer a very short reply. 0.89. What is the ratio of the Imports(as % of merchandise exports) of Barbados in 1986 to that in 1987?
Offer a very short reply. 1.08. What is the ratio of the Imports(as % of merchandise exports) of Honduras in 1986 to that in 1987?
Give a very brief answer. 0.98. What is the ratio of the Imports(as % of merchandise exports) of Mexico in 1986 to that in 1987?
Make the answer very short. 1.08. What is the ratio of the Imports(as % of merchandise exports) in Barbados in 1986 to that in 1988?
Provide a succinct answer. 1.08. What is the ratio of the Imports(as % of merchandise exports) in Honduras in 1986 to that in 1988?
Provide a short and direct response. 0.93. What is the ratio of the Imports(as % of merchandise exports) of Mexico in 1986 to that in 1988?
Your answer should be very brief. 1.15. What is the ratio of the Imports(as % of merchandise exports) of St. Lucia in 1986 to that in 1988?
Your answer should be very brief. 0.95. What is the ratio of the Imports(as % of merchandise exports) in Barbados in 1987 to that in 1988?
Make the answer very short. 0.99. What is the ratio of the Imports(as % of merchandise exports) of Honduras in 1987 to that in 1988?
Make the answer very short. 0.96. What is the ratio of the Imports(as % of merchandise exports) of Mexico in 1987 to that in 1988?
Keep it short and to the point. 1.06. What is the ratio of the Imports(as % of merchandise exports) of St. Lucia in 1987 to that in 1988?
Your answer should be compact. 0.96. What is the difference between the highest and the second highest Imports(as % of merchandise exports) of Barbados?
Your response must be concise. 2.84. What is the difference between the highest and the second highest Imports(as % of merchandise exports) of Honduras?
Your answer should be very brief. 3.12. What is the difference between the highest and the second highest Imports(as % of merchandise exports) in Mexico?
Your response must be concise. 1.17. What is the difference between the highest and the second highest Imports(as % of merchandise exports) in St. Lucia?
Your response must be concise. 2.94. What is the difference between the highest and the lowest Imports(as % of merchandise exports) in Barbados?
Offer a terse response. 8.83. What is the difference between the highest and the lowest Imports(as % of merchandise exports) of Honduras?
Offer a very short reply. 9.28. What is the difference between the highest and the lowest Imports(as % of merchandise exports) of Mexico?
Offer a terse response. 10.72. What is the difference between the highest and the lowest Imports(as % of merchandise exports) of St. Lucia?
Keep it short and to the point. 10.7. 